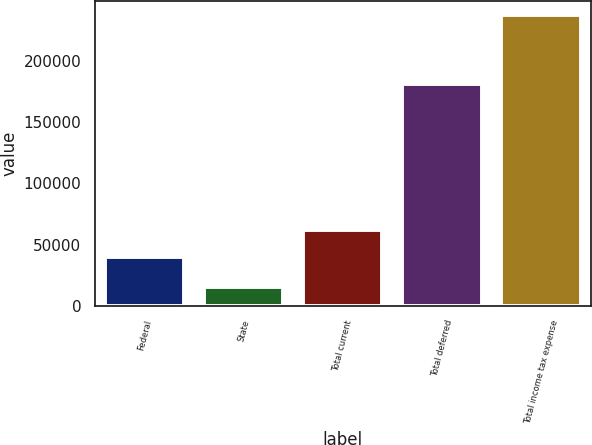<chart> <loc_0><loc_0><loc_500><loc_500><bar_chart><fcel>Federal<fcel>State<fcel>Total current<fcel>Total deferred<fcel>Total income tax expense<nl><fcel>40115<fcel>15598<fcel>62291.2<fcel>181647<fcel>237360<nl></chart> 